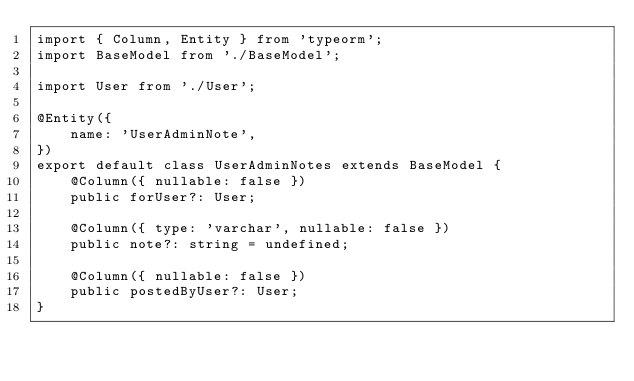<code> <loc_0><loc_0><loc_500><loc_500><_TypeScript_>import { Column, Entity } from 'typeorm';
import BaseModel from './BaseModel';

import User from './User';

@Entity({
    name: 'UserAdminNote',
})
export default class UserAdminNotes extends BaseModel {
    @Column({ nullable: false })
    public forUser?: User;

    @Column({ type: 'varchar', nullable: false })
    public note?: string = undefined;

    @Column({ nullable: false })
    public postedByUser?: User;
}
</code> 